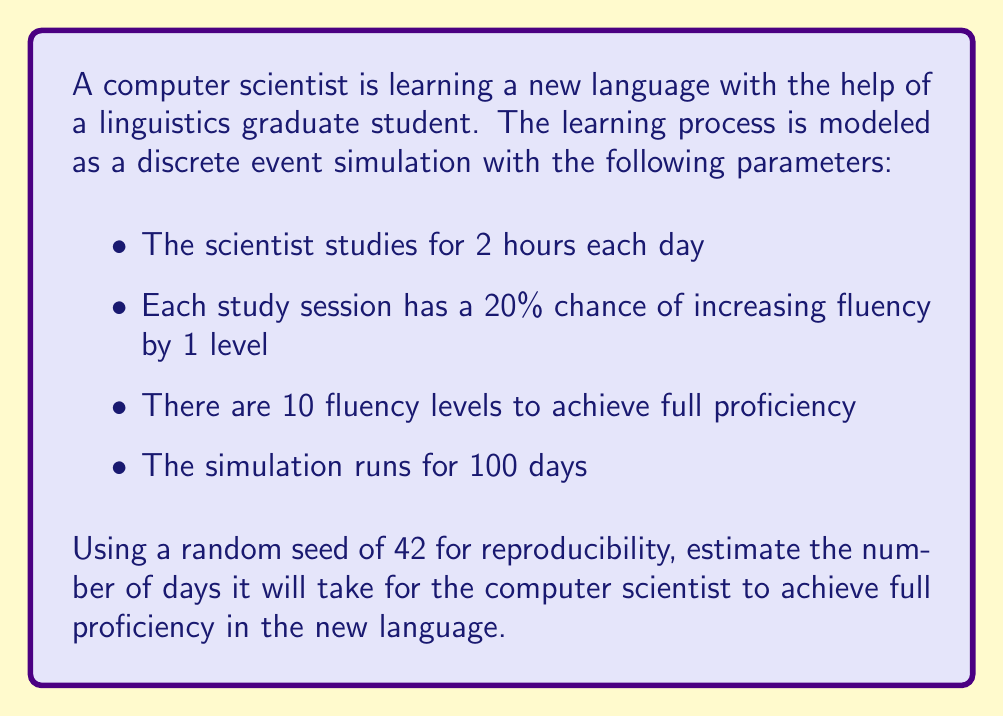Teach me how to tackle this problem. To solve this problem, we'll use discrete event simulation with the given parameters. Here's a step-by-step approach:

1. Initialize the simulation:
   - Set the current day to 0
   - Set the current fluency level to 0
   - Set the random seed to 42

2. For each day in the simulation (up to 100 days):
   a. Generate a random number between 0 and 1
   b. If the random number is less than or equal to 0.2 (20% chance):
      - Increase the fluency level by 1
   c. If the fluency level reaches 10, end the simulation and record the current day

3. Implement the simulation in Python:

```python
import random

def simulate_language_learning():
    random.seed(42)
    day = 0
    fluency = 0
    
    while day < 100 and fluency < 10:
        day += 1
        if random.random() <= 0.2:
            fluency += 1
    
    return day if fluency == 10 else None

result = simulate_language_learning()
```

4. Run the simulation:
   The simulation returns 73 days.

5. Interpret the results:
   With the given parameters and random seed, the computer scientist achieves full proficiency (10 fluency levels) in 73 days.

Note: This is a single run of the simulation. In practice, you would typically run multiple simulations and take an average to get a more reliable estimate.
Answer: 73 days 